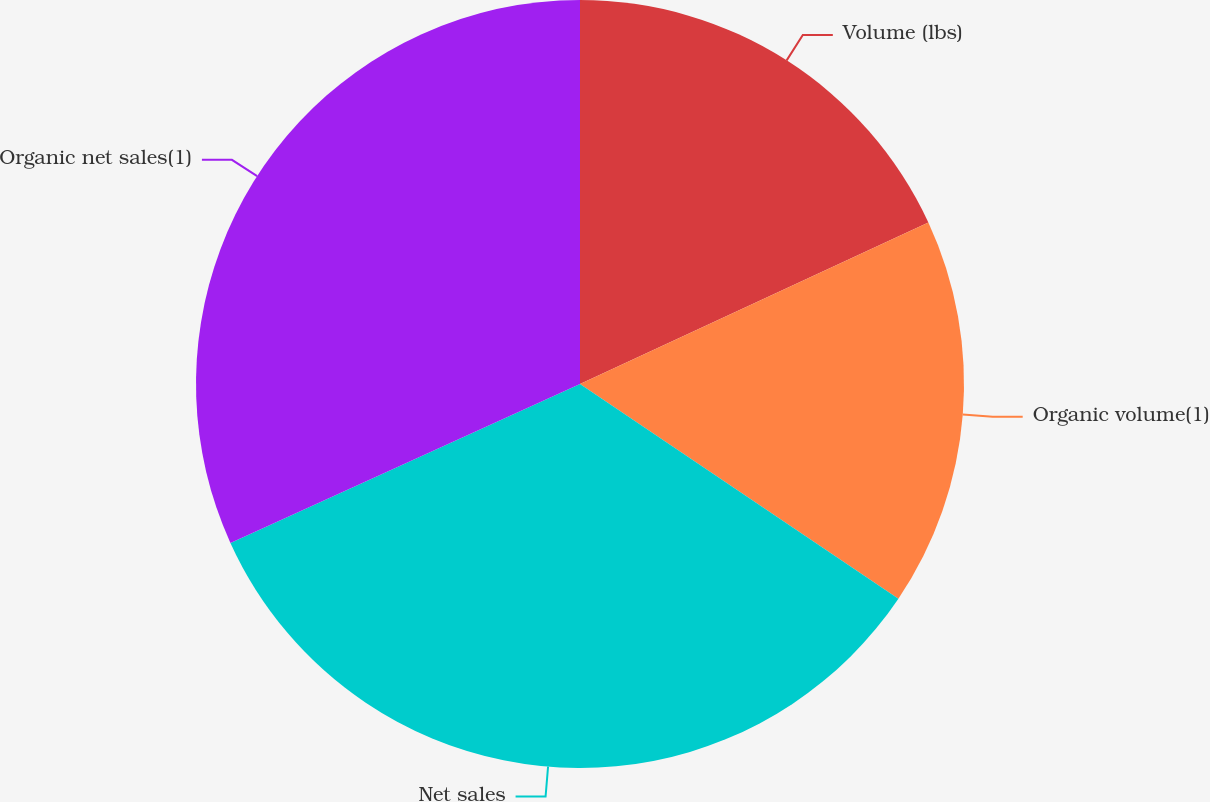Convert chart. <chart><loc_0><loc_0><loc_500><loc_500><pie_chart><fcel>Volume (lbs)<fcel>Organic volume(1)<fcel>Net sales<fcel>Organic net sales(1)<nl><fcel>18.09%<fcel>16.35%<fcel>33.77%<fcel>31.79%<nl></chart> 